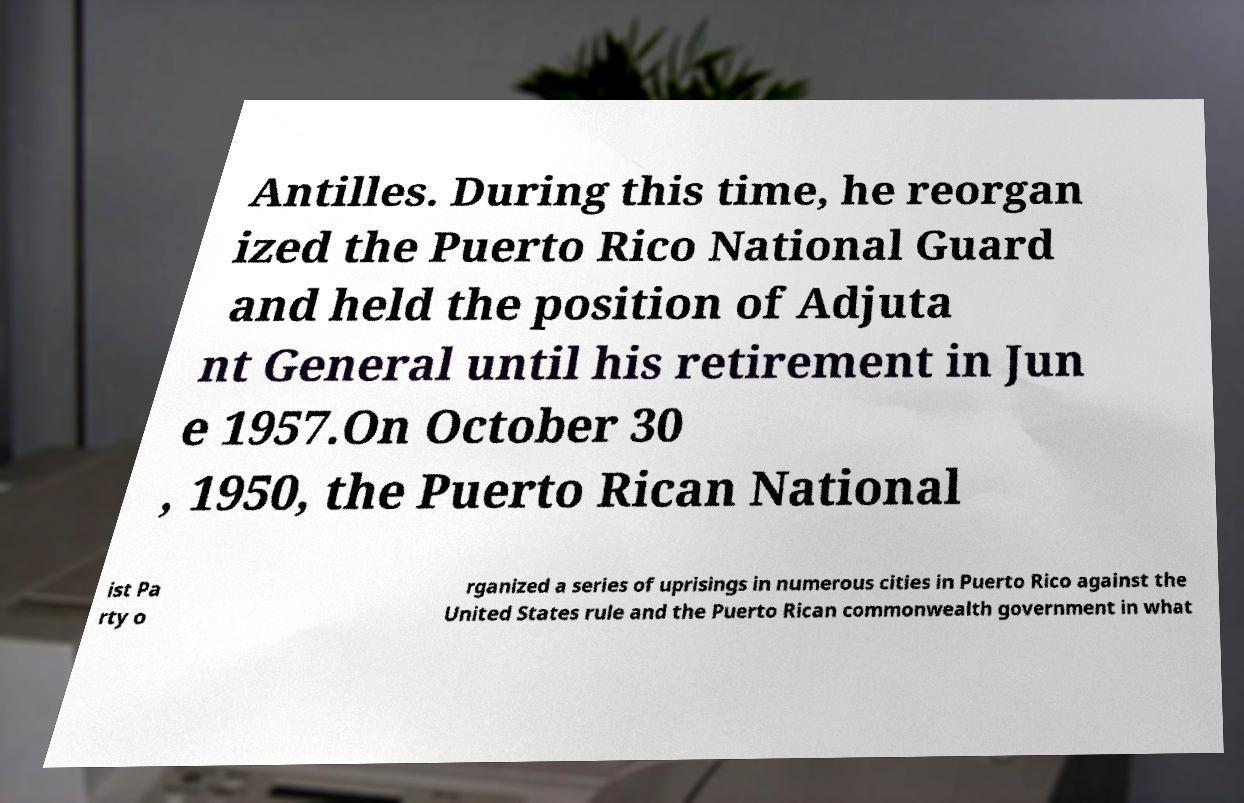Could you assist in decoding the text presented in this image and type it out clearly? Antilles. During this time, he reorgan ized the Puerto Rico National Guard and held the position of Adjuta nt General until his retirement in Jun e 1957.On October 30 , 1950, the Puerto Rican National ist Pa rty o rganized a series of uprisings in numerous cities in Puerto Rico against the United States rule and the Puerto Rican commonwealth government in what 